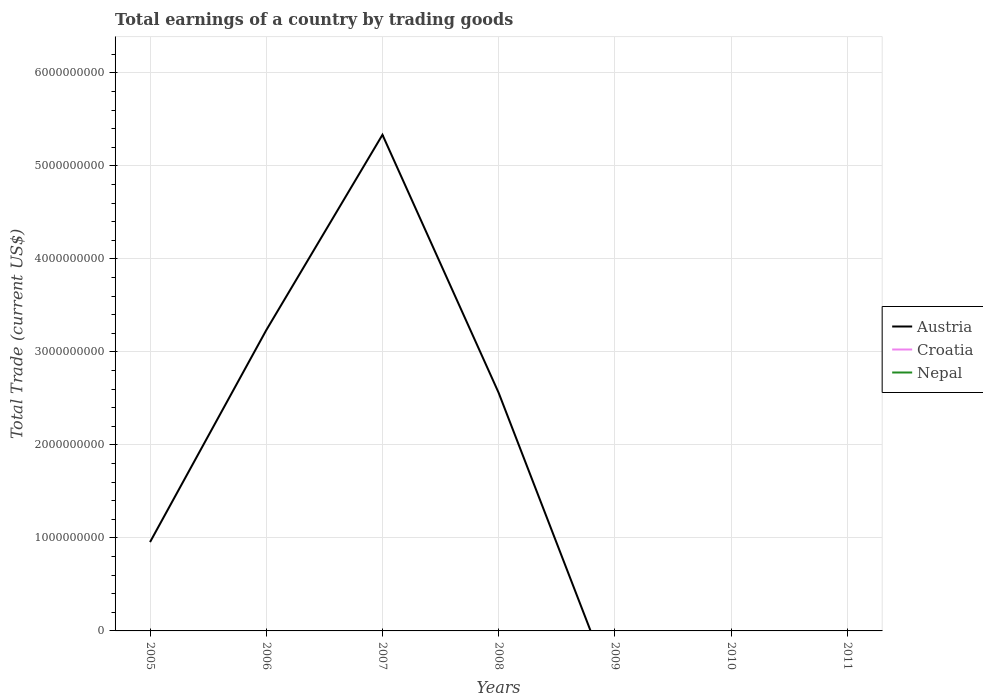Does the line corresponding to Nepal intersect with the line corresponding to Croatia?
Your answer should be compact. No. Is the number of lines equal to the number of legend labels?
Make the answer very short. No. What is the total total earnings in Austria in the graph?
Provide a short and direct response. 2.77e+09. What is the difference between the highest and the second highest total earnings in Austria?
Your answer should be compact. 5.33e+09. What is the difference between the highest and the lowest total earnings in Austria?
Provide a succinct answer. 3. Is the total earnings in Austria strictly greater than the total earnings in Croatia over the years?
Offer a very short reply. No. What is the difference between two consecutive major ticks on the Y-axis?
Ensure brevity in your answer.  1.00e+09. Are the values on the major ticks of Y-axis written in scientific E-notation?
Offer a terse response. No. Where does the legend appear in the graph?
Offer a terse response. Center right. How many legend labels are there?
Your answer should be compact. 3. How are the legend labels stacked?
Keep it short and to the point. Vertical. What is the title of the graph?
Offer a very short reply. Total earnings of a country by trading goods. Does "Portugal" appear as one of the legend labels in the graph?
Your answer should be very brief. No. What is the label or title of the X-axis?
Give a very brief answer. Years. What is the label or title of the Y-axis?
Make the answer very short. Total Trade (current US$). What is the Total Trade (current US$) in Austria in 2005?
Give a very brief answer. 9.55e+08. What is the Total Trade (current US$) of Nepal in 2005?
Your answer should be compact. 0. What is the Total Trade (current US$) of Austria in 2006?
Make the answer very short. 3.23e+09. What is the Total Trade (current US$) of Croatia in 2006?
Provide a succinct answer. 0. What is the Total Trade (current US$) in Nepal in 2006?
Your answer should be very brief. 0. What is the Total Trade (current US$) in Austria in 2007?
Provide a succinct answer. 5.33e+09. What is the Total Trade (current US$) in Austria in 2008?
Ensure brevity in your answer.  2.56e+09. What is the Total Trade (current US$) in Croatia in 2008?
Your response must be concise. 0. What is the Total Trade (current US$) of Nepal in 2008?
Ensure brevity in your answer.  0. What is the Total Trade (current US$) of Austria in 2009?
Keep it short and to the point. 0. What is the Total Trade (current US$) in Croatia in 2009?
Make the answer very short. 0. What is the Total Trade (current US$) of Austria in 2010?
Your response must be concise. 0. What is the Total Trade (current US$) in Croatia in 2010?
Your response must be concise. 0. What is the Total Trade (current US$) of Austria in 2011?
Give a very brief answer. 0. What is the Total Trade (current US$) in Nepal in 2011?
Provide a short and direct response. 0. Across all years, what is the maximum Total Trade (current US$) of Austria?
Provide a short and direct response. 5.33e+09. Across all years, what is the minimum Total Trade (current US$) of Austria?
Ensure brevity in your answer.  0. What is the total Total Trade (current US$) of Austria in the graph?
Your answer should be very brief. 1.21e+1. What is the difference between the Total Trade (current US$) in Austria in 2005 and that in 2006?
Make the answer very short. -2.28e+09. What is the difference between the Total Trade (current US$) of Austria in 2005 and that in 2007?
Make the answer very short. -4.38e+09. What is the difference between the Total Trade (current US$) in Austria in 2005 and that in 2008?
Ensure brevity in your answer.  -1.60e+09. What is the difference between the Total Trade (current US$) in Austria in 2006 and that in 2007?
Give a very brief answer. -2.10e+09. What is the difference between the Total Trade (current US$) in Austria in 2006 and that in 2008?
Your answer should be very brief. 6.74e+08. What is the difference between the Total Trade (current US$) in Austria in 2007 and that in 2008?
Ensure brevity in your answer.  2.77e+09. What is the average Total Trade (current US$) in Austria per year?
Offer a very short reply. 1.73e+09. What is the average Total Trade (current US$) in Croatia per year?
Your answer should be compact. 0. What is the average Total Trade (current US$) of Nepal per year?
Your answer should be compact. 0. What is the ratio of the Total Trade (current US$) of Austria in 2005 to that in 2006?
Ensure brevity in your answer.  0.3. What is the ratio of the Total Trade (current US$) of Austria in 2005 to that in 2007?
Keep it short and to the point. 0.18. What is the ratio of the Total Trade (current US$) in Austria in 2005 to that in 2008?
Your answer should be compact. 0.37. What is the ratio of the Total Trade (current US$) of Austria in 2006 to that in 2007?
Your answer should be very brief. 0.61. What is the ratio of the Total Trade (current US$) of Austria in 2006 to that in 2008?
Your answer should be very brief. 1.26. What is the ratio of the Total Trade (current US$) in Austria in 2007 to that in 2008?
Give a very brief answer. 2.08. What is the difference between the highest and the second highest Total Trade (current US$) in Austria?
Ensure brevity in your answer.  2.10e+09. What is the difference between the highest and the lowest Total Trade (current US$) in Austria?
Your answer should be compact. 5.33e+09. 